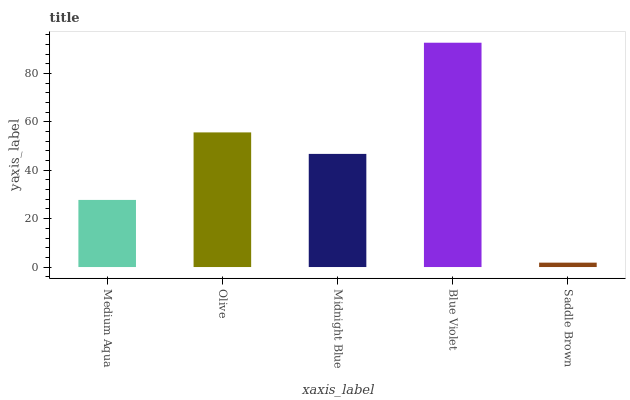Is Saddle Brown the minimum?
Answer yes or no. Yes. Is Blue Violet the maximum?
Answer yes or no. Yes. Is Olive the minimum?
Answer yes or no. No. Is Olive the maximum?
Answer yes or no. No. Is Olive greater than Medium Aqua?
Answer yes or no. Yes. Is Medium Aqua less than Olive?
Answer yes or no. Yes. Is Medium Aqua greater than Olive?
Answer yes or no. No. Is Olive less than Medium Aqua?
Answer yes or no. No. Is Midnight Blue the high median?
Answer yes or no. Yes. Is Midnight Blue the low median?
Answer yes or no. Yes. Is Saddle Brown the high median?
Answer yes or no. No. Is Medium Aqua the low median?
Answer yes or no. No. 